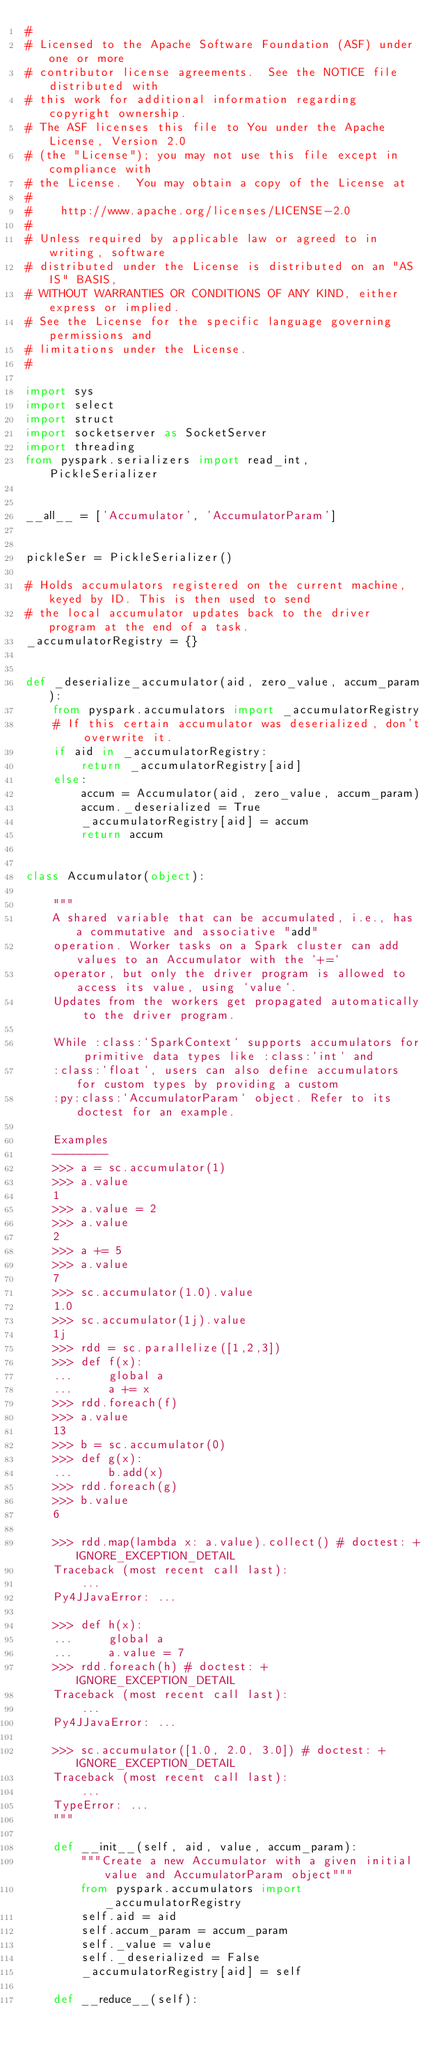Convert code to text. <code><loc_0><loc_0><loc_500><loc_500><_Python_>#
# Licensed to the Apache Software Foundation (ASF) under one or more
# contributor license agreements.  See the NOTICE file distributed with
# this work for additional information regarding copyright ownership.
# The ASF licenses this file to You under the Apache License, Version 2.0
# (the "License"); you may not use this file except in compliance with
# the License.  You may obtain a copy of the License at
#
#    http://www.apache.org/licenses/LICENSE-2.0
#
# Unless required by applicable law or agreed to in writing, software
# distributed under the License is distributed on an "AS IS" BASIS,
# WITHOUT WARRANTIES OR CONDITIONS OF ANY KIND, either express or implied.
# See the License for the specific language governing permissions and
# limitations under the License.
#

import sys
import select
import struct
import socketserver as SocketServer
import threading
from pyspark.serializers import read_int, PickleSerializer


__all__ = ['Accumulator', 'AccumulatorParam']


pickleSer = PickleSerializer()

# Holds accumulators registered on the current machine, keyed by ID. This is then used to send
# the local accumulator updates back to the driver program at the end of a task.
_accumulatorRegistry = {}


def _deserialize_accumulator(aid, zero_value, accum_param):
    from pyspark.accumulators import _accumulatorRegistry
    # If this certain accumulator was deserialized, don't overwrite it.
    if aid in _accumulatorRegistry:
        return _accumulatorRegistry[aid]
    else:
        accum = Accumulator(aid, zero_value, accum_param)
        accum._deserialized = True
        _accumulatorRegistry[aid] = accum
        return accum


class Accumulator(object):

    """
    A shared variable that can be accumulated, i.e., has a commutative and associative "add"
    operation. Worker tasks on a Spark cluster can add values to an Accumulator with the `+=`
    operator, but only the driver program is allowed to access its value, using `value`.
    Updates from the workers get propagated automatically to the driver program.

    While :class:`SparkContext` supports accumulators for primitive data types like :class:`int` and
    :class:`float`, users can also define accumulators for custom types by providing a custom
    :py:class:`AccumulatorParam` object. Refer to its doctest for an example.

    Examples
    --------
    >>> a = sc.accumulator(1)
    >>> a.value
    1
    >>> a.value = 2
    >>> a.value
    2
    >>> a += 5
    >>> a.value
    7
    >>> sc.accumulator(1.0).value
    1.0
    >>> sc.accumulator(1j).value
    1j
    >>> rdd = sc.parallelize([1,2,3])
    >>> def f(x):
    ...     global a
    ...     a += x
    >>> rdd.foreach(f)
    >>> a.value
    13
    >>> b = sc.accumulator(0)
    >>> def g(x):
    ...     b.add(x)
    >>> rdd.foreach(g)
    >>> b.value
    6

    >>> rdd.map(lambda x: a.value).collect() # doctest: +IGNORE_EXCEPTION_DETAIL
    Traceback (most recent call last):
        ...
    Py4JJavaError: ...

    >>> def h(x):
    ...     global a
    ...     a.value = 7
    >>> rdd.foreach(h) # doctest: +IGNORE_EXCEPTION_DETAIL
    Traceback (most recent call last):
        ...
    Py4JJavaError: ...

    >>> sc.accumulator([1.0, 2.0, 3.0]) # doctest: +IGNORE_EXCEPTION_DETAIL
    Traceback (most recent call last):
        ...
    TypeError: ...
    """

    def __init__(self, aid, value, accum_param):
        """Create a new Accumulator with a given initial value and AccumulatorParam object"""
        from pyspark.accumulators import _accumulatorRegistry
        self.aid = aid
        self.accum_param = accum_param
        self._value = value
        self._deserialized = False
        _accumulatorRegistry[aid] = self

    def __reduce__(self):</code> 